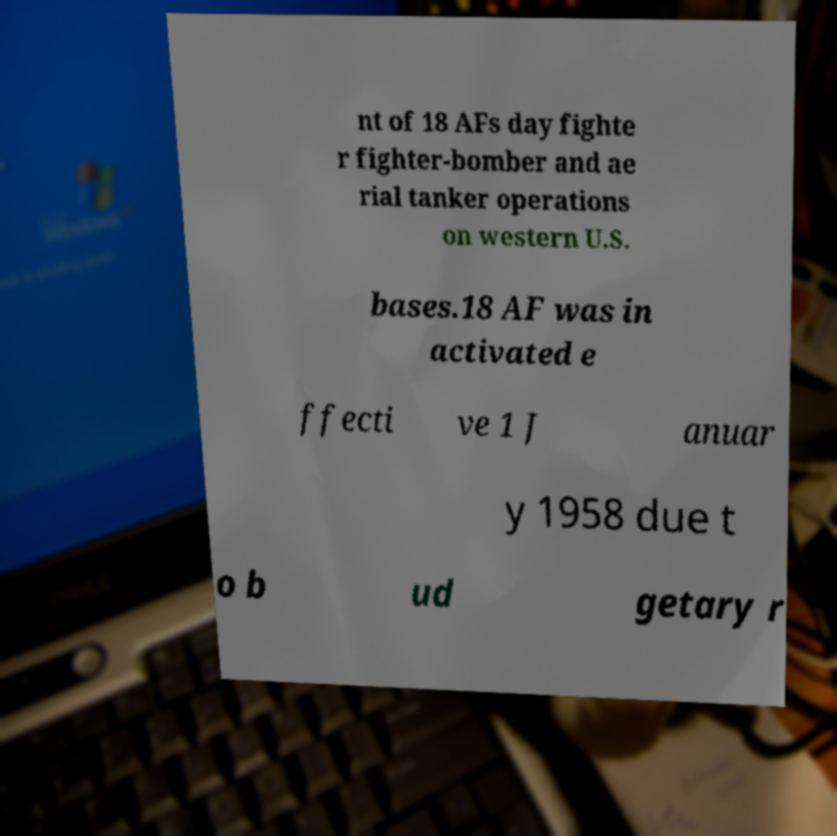Can you accurately transcribe the text from the provided image for me? nt of 18 AFs day fighte r fighter-bomber and ae rial tanker operations on western U.S. bases.18 AF was in activated e ffecti ve 1 J anuar y 1958 due t o b ud getary r 